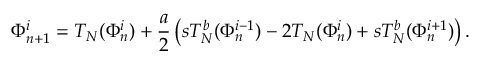<formula> <loc_0><loc_0><loc_500><loc_500>\Phi _ { n + 1 } ^ { i } = T _ { N } ( \Phi _ { n } ^ { i } ) + \frac { a } { 2 } \left ( s T _ { N } ^ { b } ( \Phi _ { n } ^ { i - 1 } ) - 2 T _ { N } ( \Phi _ { n } ^ { i } ) + s T _ { N } ^ { b } ( \Phi _ { n } ^ { i + 1 } ) \right ) .</formula> 